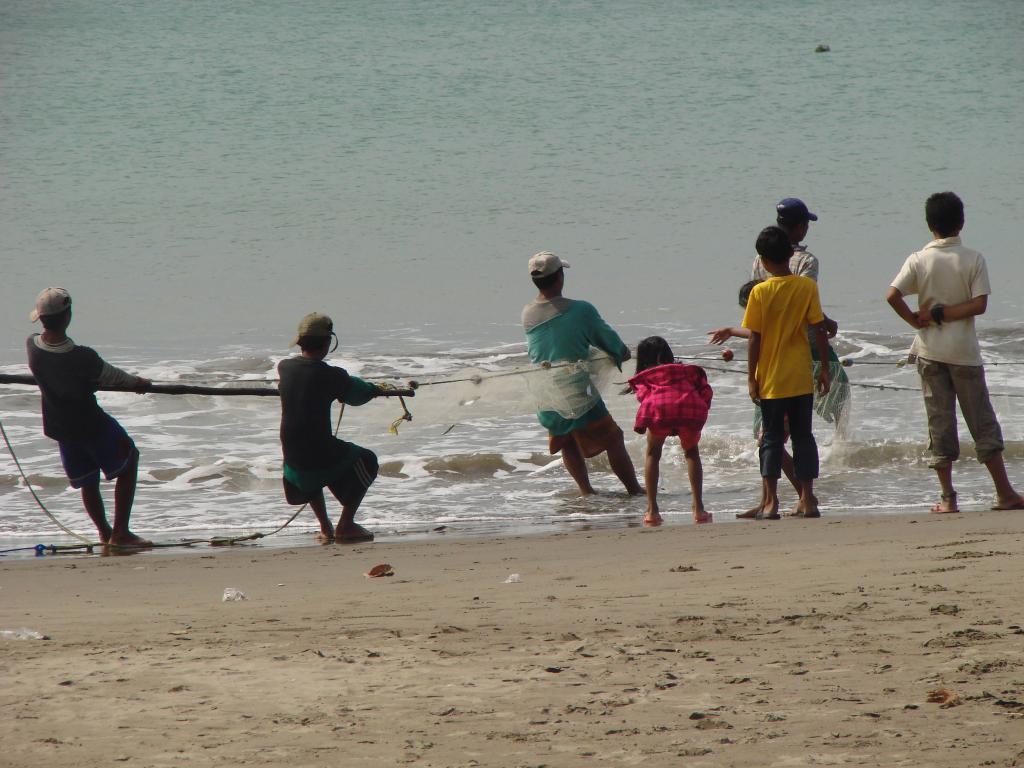In one or two sentences, can you explain what this image depicts? This image consists of few people. They are catching fishes in a net. At the bottom, there is sand. In the front, we can see the water. It looks like it is clicked near the ocean. 